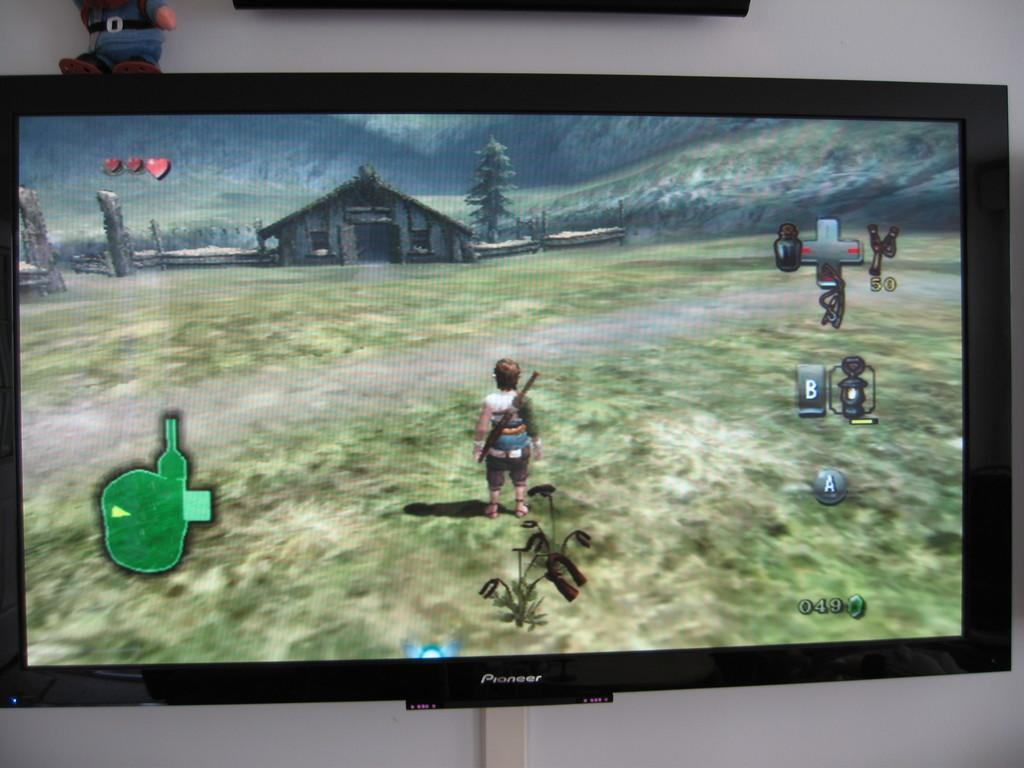<image>
Offer a succinct explanation of the picture presented. Someone playing a Legend of Zelda game on a Pioneer television. 